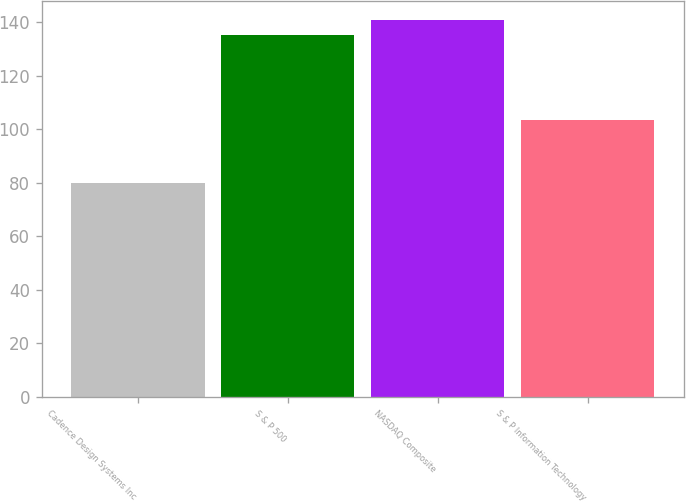<chart> <loc_0><loc_0><loc_500><loc_500><bar_chart><fcel>Cadence Design Systems Inc<fcel>S & P 500<fcel>NASDAQ Composite<fcel>S & P Information Technology<nl><fcel>79.96<fcel>135.03<fcel>140.74<fcel>103.47<nl></chart> 